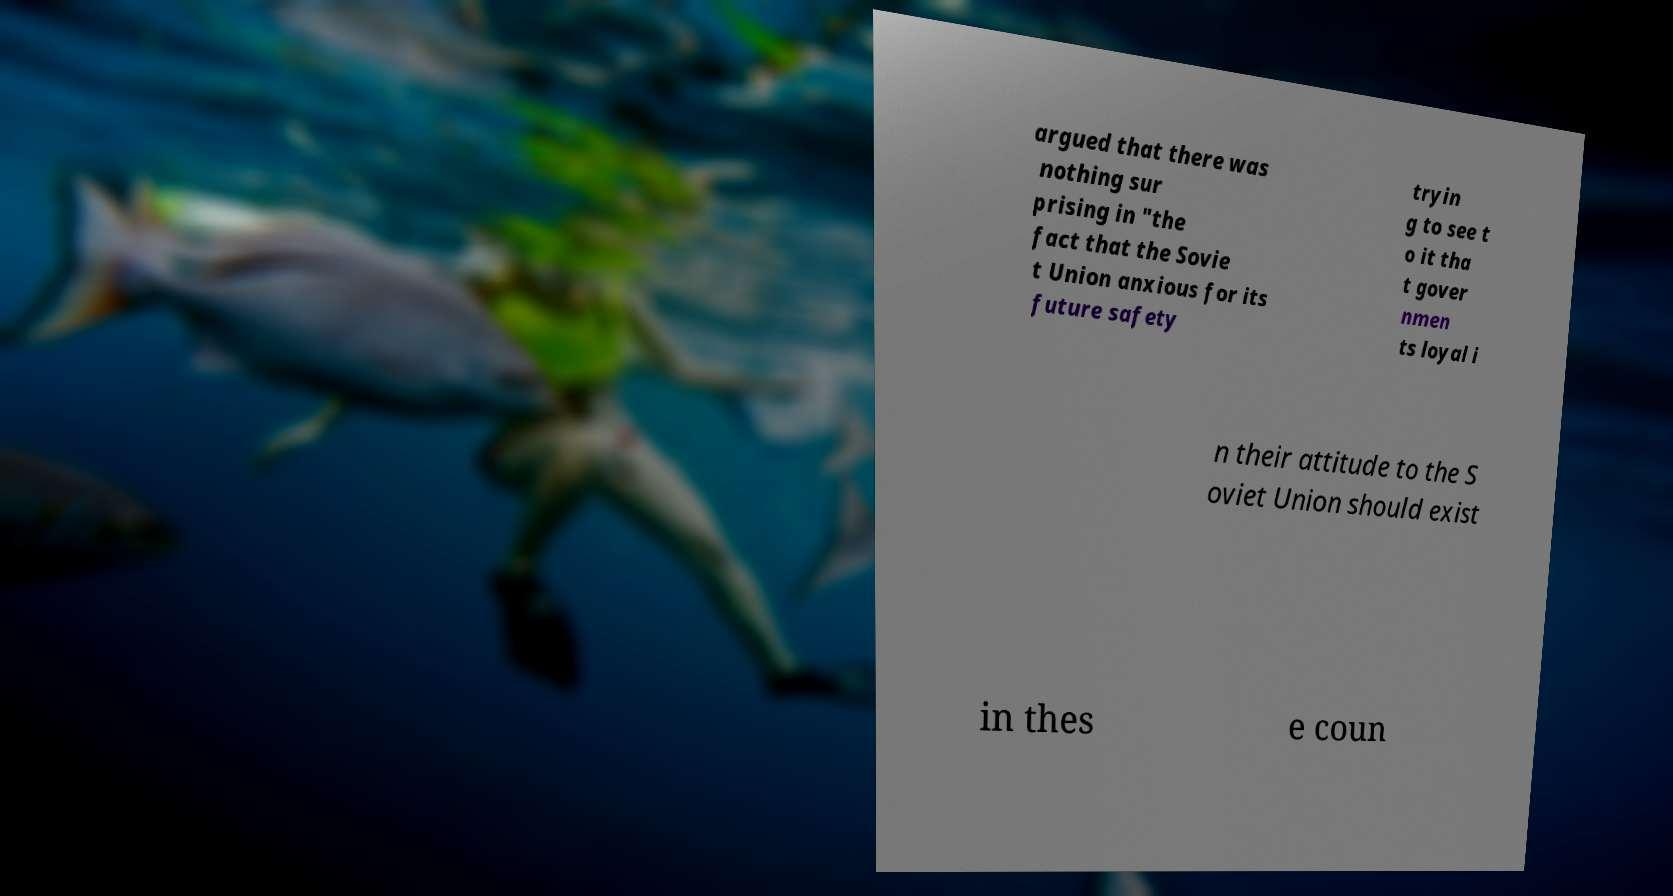There's text embedded in this image that I need extracted. Can you transcribe it verbatim? argued that there was nothing sur prising in "the fact that the Sovie t Union anxious for its future safety tryin g to see t o it tha t gover nmen ts loyal i n their attitude to the S oviet Union should exist in thes e coun 